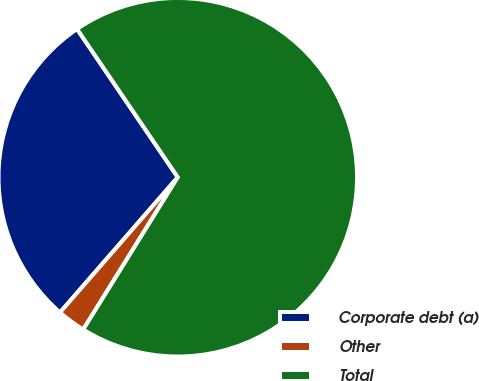<chart> <loc_0><loc_0><loc_500><loc_500><pie_chart><fcel>Corporate debt (a)<fcel>Other<fcel>Total<nl><fcel>29.1%<fcel>2.56%<fcel>68.34%<nl></chart> 